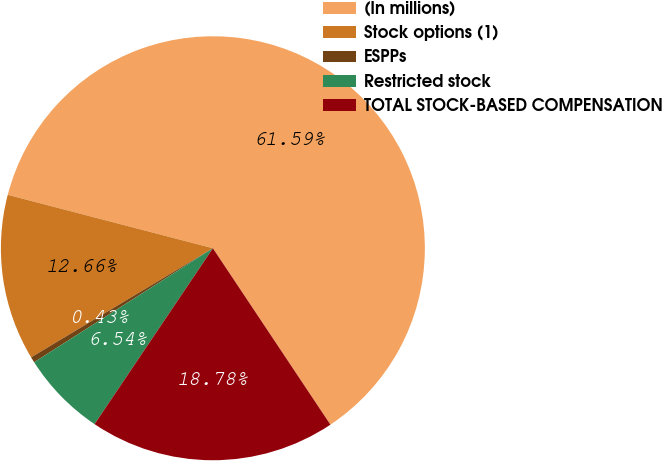Convert chart to OTSL. <chart><loc_0><loc_0><loc_500><loc_500><pie_chart><fcel>(In millions)<fcel>Stock options (1)<fcel>ESPPs<fcel>Restricted stock<fcel>TOTAL STOCK-BASED COMPENSATION<nl><fcel>61.59%<fcel>12.66%<fcel>0.43%<fcel>6.54%<fcel>18.78%<nl></chart> 